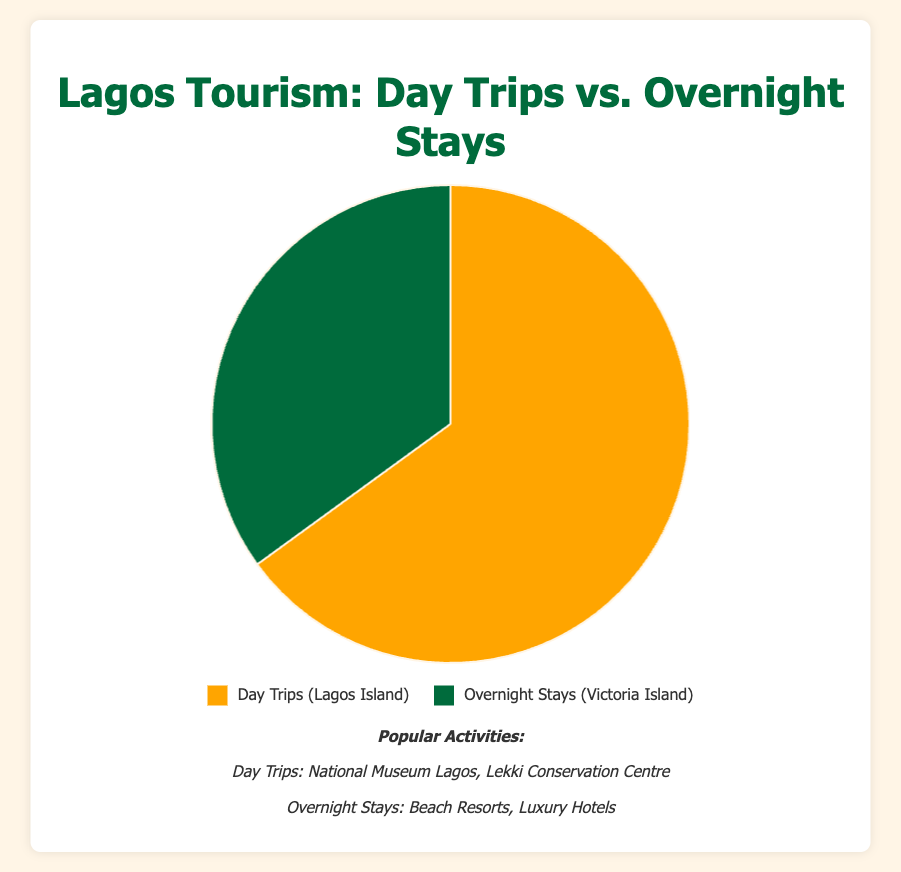What's the percentage of tourists who prefer Day Trips? The chart shows that tourists who prefer Day Trips are represented by 65% of the total. This value is directly indicated on the chart.
Answer: 65% What's the difference in percentage between Day Trips and Overnight Stays? The chart indicates that Day Trips account for 65% while Overnight Stays account for 35%. The difference is calculated by subtracting the smaller percentage from the larger one: 65% - 35% = 30%.
Answer: 30% Which type of tourism brings in more visitors, Day Trips or Overnight Stays? According to the chart, Day Trips have a higher percentage (65%) compared to Overnight Stays (35%). Hence, Day Trips bring in more visitors.
Answer: Day Trips If there are 10,000 tourists, how many of them are likely to take Overnight Stays? 35% of the tourists are indicated to take Overnight Stays. To find the number of such tourists out of 10,000, we calculate 35% of 10,000: (35/100) * 10,000 = 3,500.
Answer: 3,500 What activities are associated with Day Trips? The chart lists the popular activities for Day Trips on Lagos Island, which include the National Museum Lagos and Lekki Conservation Centre.
Answer: National Museum Lagos, Lekki Conservation Centre Based on the chart, which color represents Overnight Stays? The chart uses a color legend showing that Overnight Stays are represented by the green color.
Answer: Green Which location is linked with the highest percentage of tourist activities? The chart indicates that Lagos Island, associated with Day Trips, has the highest percentage of tourist activities at 65%.
Answer: Lagos Island What is the overall percentage represented by both categories combined? Adding the percentages for Day Trips (65%) and Overnight Stays (35%) gives the total percentage: 65% + 35% = 100%.
Answer: 100% What activities are listed for Overnight Stays? The chart highlights popular activities for Overnight Stays on Victoria Island, including Beach Resorts and Luxury Hotels.
Answer: Beach Resorts, Luxury Hotels Is the percentage of Overnight Stays more than half of the percentage of Day Trips? The percentage of Overnight Stays is 35%, which is less than half of the percentage of Day Trips (65%). Specifically, half of 65% is 32.5%, so 35% is slightly more than half.
Answer: Yes 